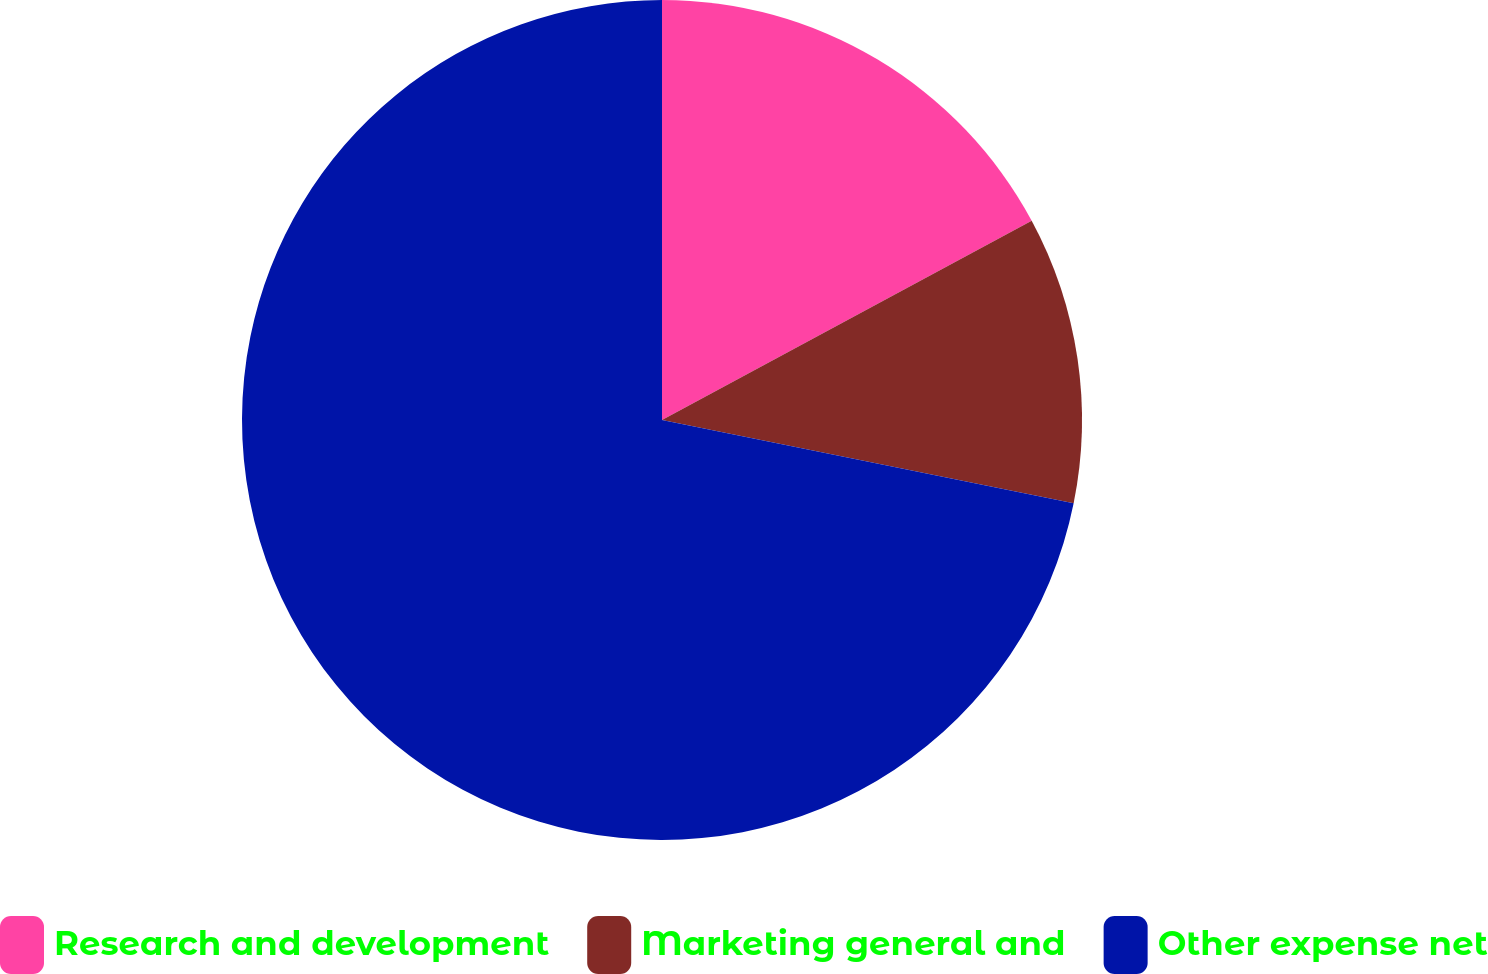Convert chart to OTSL. <chart><loc_0><loc_0><loc_500><loc_500><pie_chart><fcel>Research and development<fcel>Marketing general and<fcel>Other expense net<nl><fcel>17.13%<fcel>11.05%<fcel>71.82%<nl></chart> 